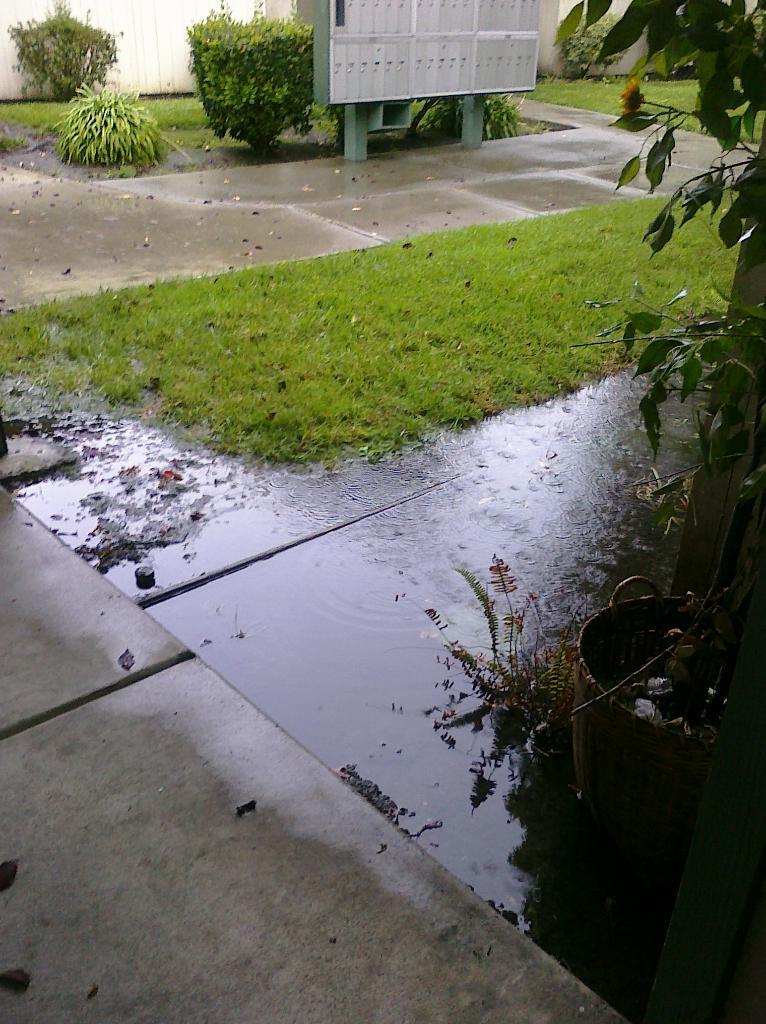Describe this image in one or two sentences. In this image there is water stagnation on the floor, beside the water, there is grass on the surface and there are a few plants and there is an electric board. 